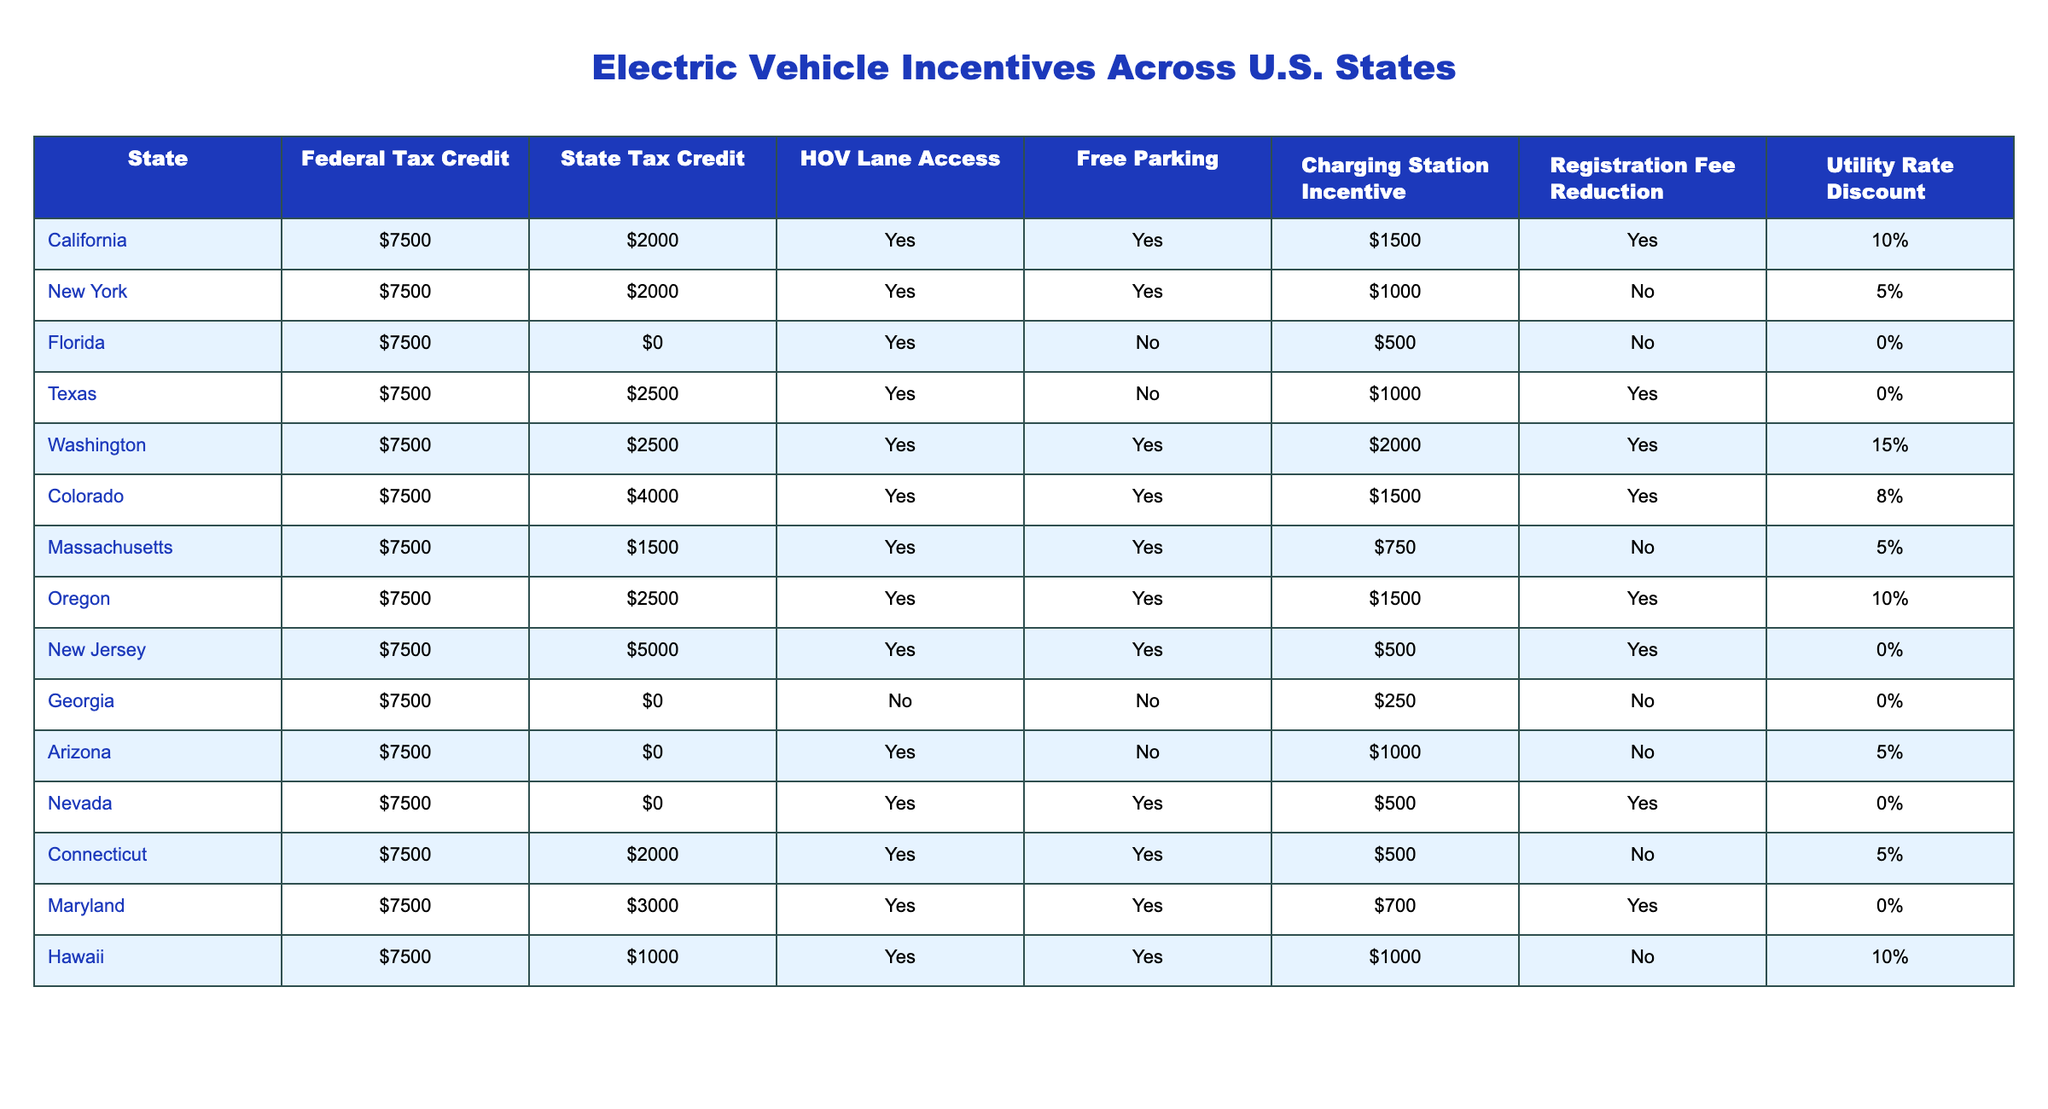What is the highest state tax credit available? The highest state tax credit listed in the table is $5000, which is provided by New Jersey.
Answer: $5000 How many states offer free parking for electric vehicles? According to the table, free parking is offered in California, New York, Washington, Colorado, Massachusetts, Oregon, New Jersey, Maryland, and Hawaii, totaling 9 states.
Answer: 9 states Is there a utility rate discount in Texas? Looking at the table, Texas has a utility rate discount listed as 0%, which means there is no discount.
Answer: No What is the total amount of incentives (federal and state tax credits) for electric vehicles in Colorado? In Colorado, the federal tax credit is $7500 and the state tax credit is $4000. The total is calculated as $7500 + $4000 = $11500.
Answer: $11500 Which state has the lowest federal tax credit? All states listed in the table offer a federal tax credit of $7500, so no state has a lower amount than this.
Answer: All states have the same federal credit How many states provide charging station incentives of more than $1000? The table shows that the states with charging station incentives greater than $1000 are California ($1500), Washington ($2000), Colorado ($1500), and Texas ($1000), totaling 3 states (excluding Texas since it's not over $1000).
Answer: 3 states Which state provides both HOV lane access and a state tax credit of at least $2000? The states that fulfill this criteria are California, Texas, Washington, Colorado, and New Jersey. That's a total of 5 states.
Answer: 5 states What is the average federal tax credit across all listed states? Since every state has a uniform federal tax credit of $7500, the average remains $7500 regardless of the number of states listed.
Answer: $7500 How many states have no state tax credit for electric vehicles? The states of Florida, Georgia, Arizona, and Nevada do not offer any state tax credit, which amounts to 4 states in total.
Answer: 4 states Is there a state that offers both HOV lane access and a registration fee reduction? The table indicates that states like California, Texas, Washington, Colorado, New Jersey, Maryland, and Hawaii all offer both HOV lane access and a registration fee reduction. That accounts for 7 states.
Answer: 7 states 